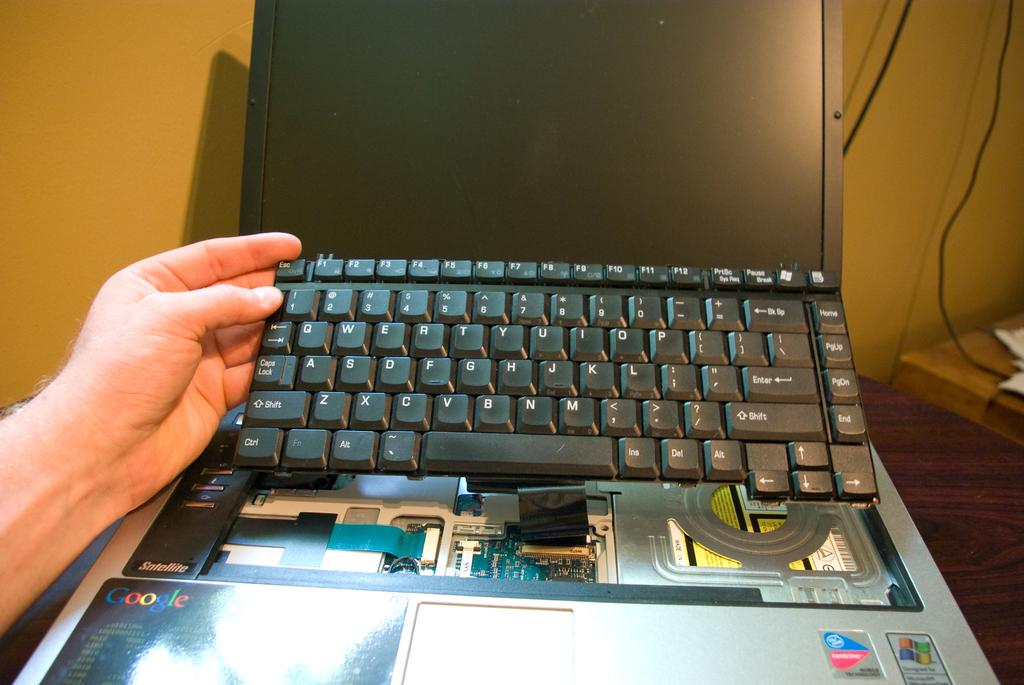<image>
Share a concise interpretation of the image provided. A human holding  keyboard of a google laptop. 